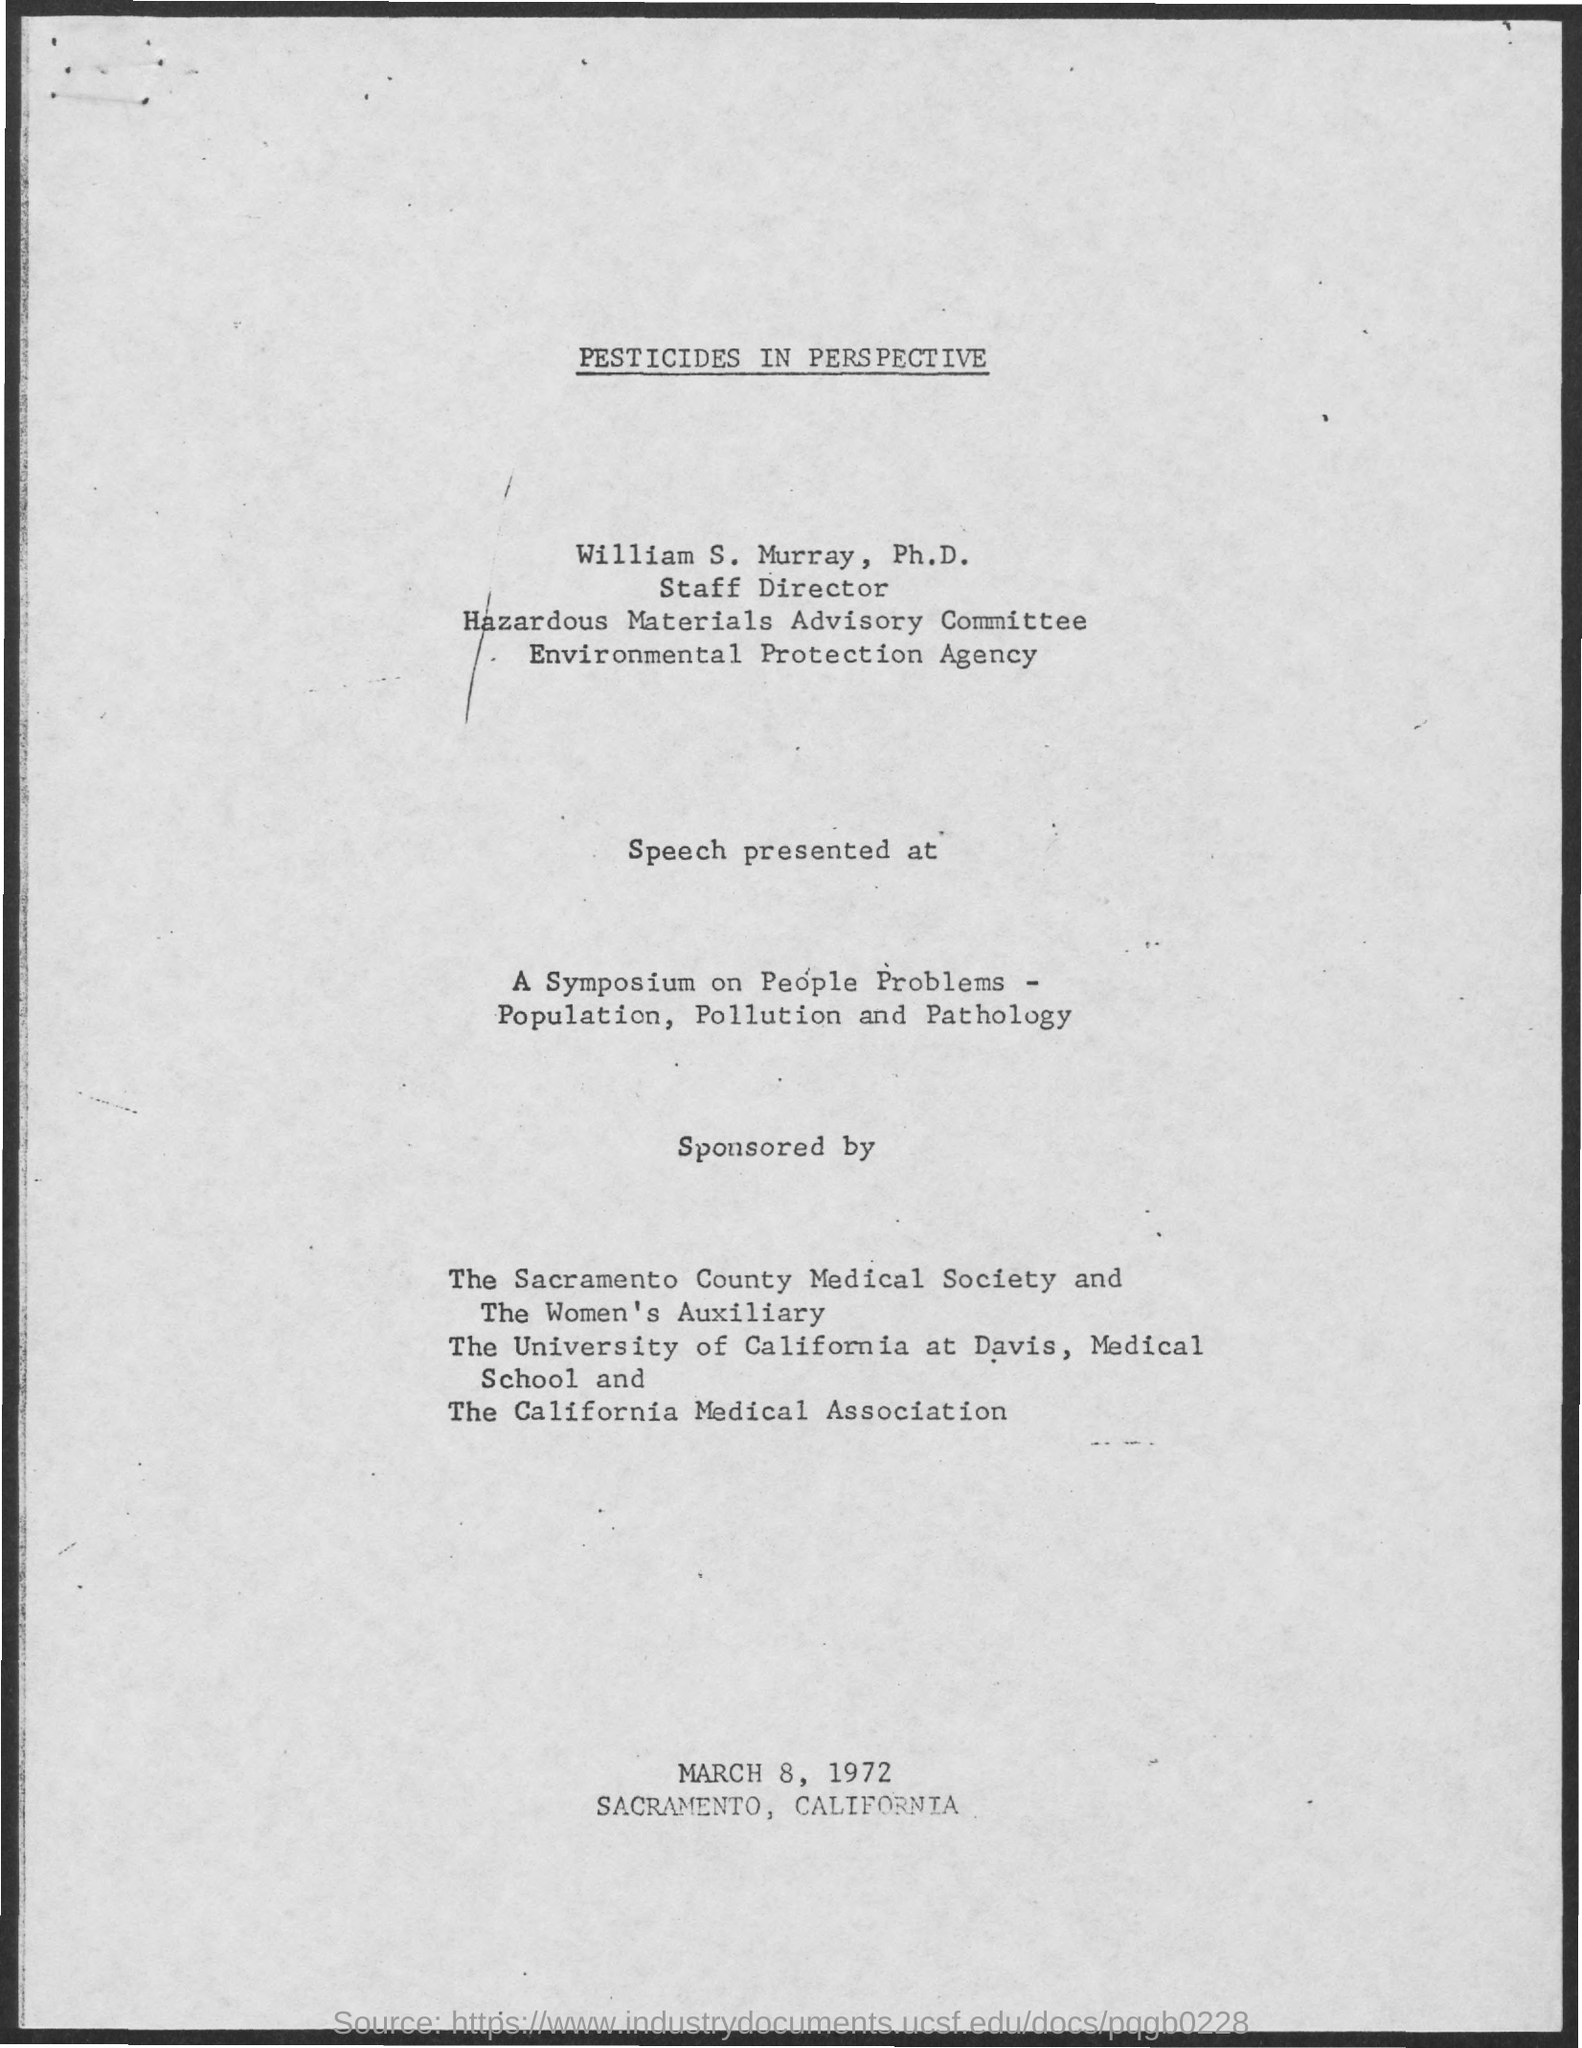Give some essential details in this illustration. The staff director of the Hazardous Materials Advisory Committee is named William S. Murray. 